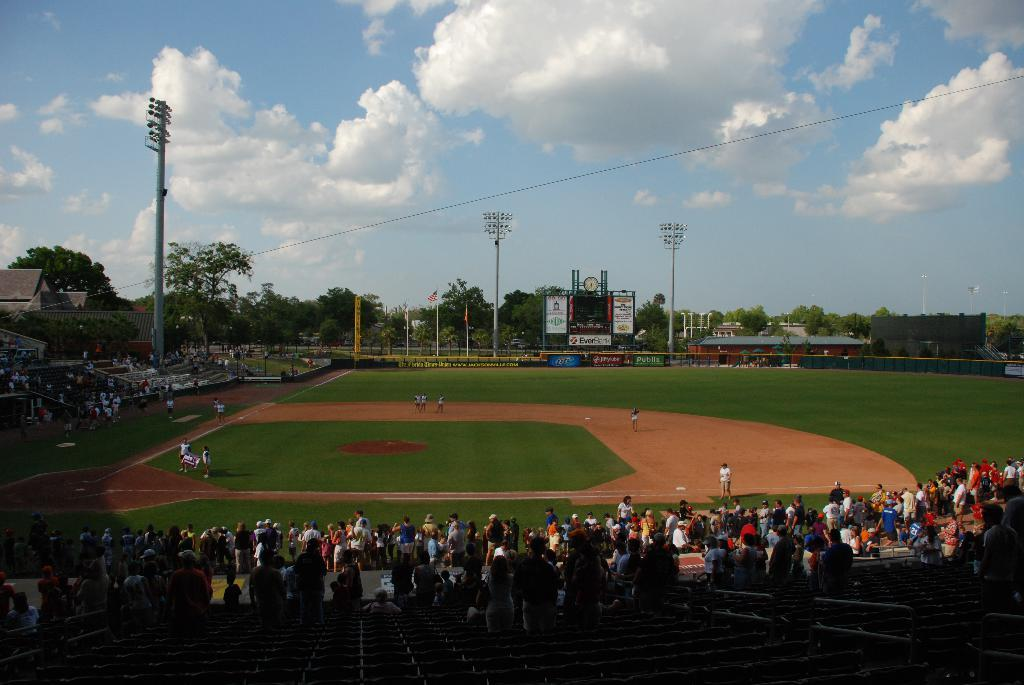What type of recreational area is visible in the image? There is a playground in the image. Can you describe the people in the image? There is a crowd in the image. What structures can be seen in the image? There are poles and fencing in the image. What type of vegetation is present in the image? There are trees in the image. What is visible at the top of the image? The sky is visible at the top of the image, and clouds are present in the sky. What type of pin can be seen holding up the cork in the image? There is no pin or cork present in the image; it features a playground, a crowd, poles, fencing, trees, and a sky with clouds. What color is the toothbrush used by the person in the image? There is no toothbrush or person present in the image. 